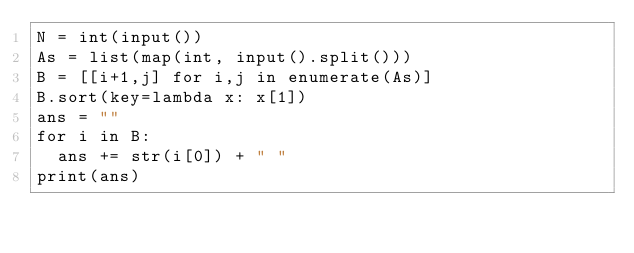Convert code to text. <code><loc_0><loc_0><loc_500><loc_500><_Python_>N = int(input())
As = list(map(int, input().split()))
B = [[i+1,j] for i,j in enumerate(As)]
B.sort(key=lambda x: x[1])
ans = ""
for i in B:
  ans += str(i[0]) + " "
print(ans)</code> 